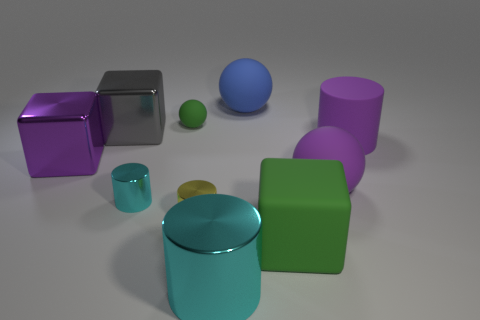Subtract all purple balls. How many balls are left? 2 Subtract all green balls. How many balls are left? 2 Subtract all purple spheres. How many cyan cylinders are left? 2 Subtract 1 balls. How many balls are left? 2 Subtract all cubes. How many objects are left? 7 Add 3 purple cylinders. How many purple cylinders are left? 4 Add 9 gray spheres. How many gray spheres exist? 9 Subtract 0 yellow spheres. How many objects are left? 10 Subtract all green cylinders. Subtract all cyan spheres. How many cylinders are left? 4 Subtract all shiny blocks. Subtract all green rubber things. How many objects are left? 6 